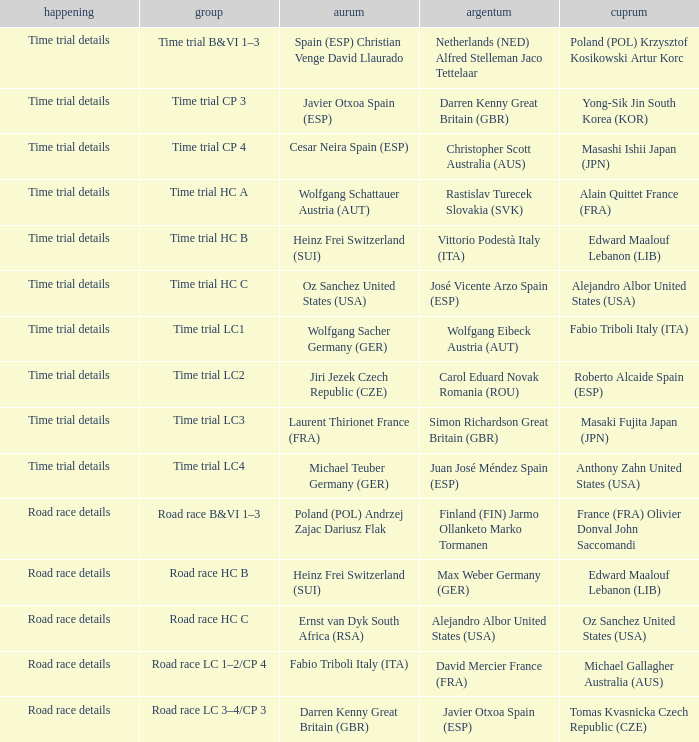What is the event when gold is darren kenny great britain (gbr)? Road race details. 